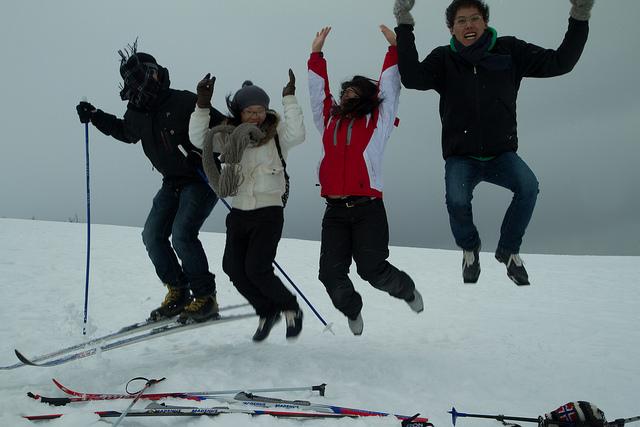What is this person standing on?
Keep it brief. Skis. Are the people on the ground?
Short answer required. No. What color is the brightest jacket?
Keep it brief. Red. Are the people happy?
Write a very short answer. Yes. 